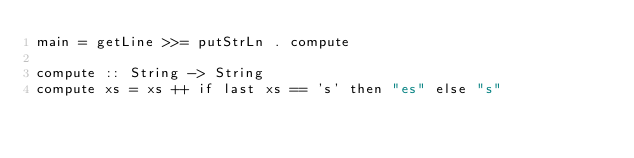Convert code to text. <code><loc_0><loc_0><loc_500><loc_500><_Haskell_>main = getLine >>= putStrLn . compute

compute :: String -> String
compute xs = xs ++ if last xs == 's' then "es" else "s"
</code> 